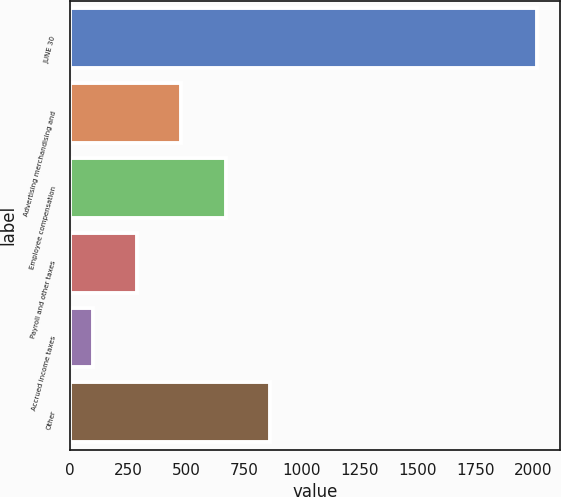<chart> <loc_0><loc_0><loc_500><loc_500><bar_chart><fcel>JUNE 30<fcel>Advertising merchandising and<fcel>Employee compensation<fcel>Payroll and other taxes<fcel>Accrued income taxes<fcel>Other<nl><fcel>2015<fcel>480.52<fcel>672.33<fcel>288.71<fcel>96.9<fcel>864.14<nl></chart> 